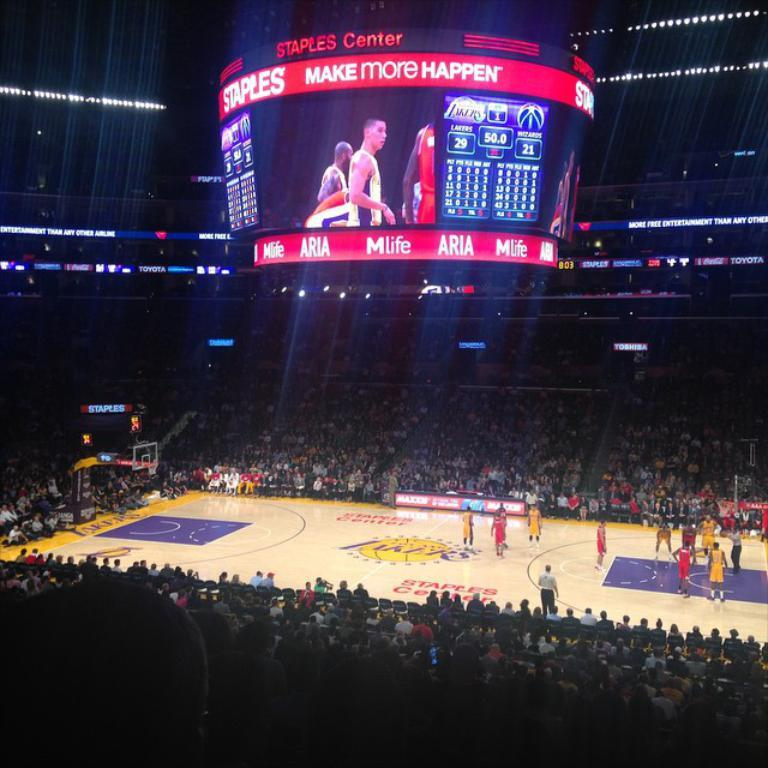<image>
Create a compact narrative representing the image presented. A Lakers game is underway at Staples center, with the scoreboard showing a 29 to 21 score. 